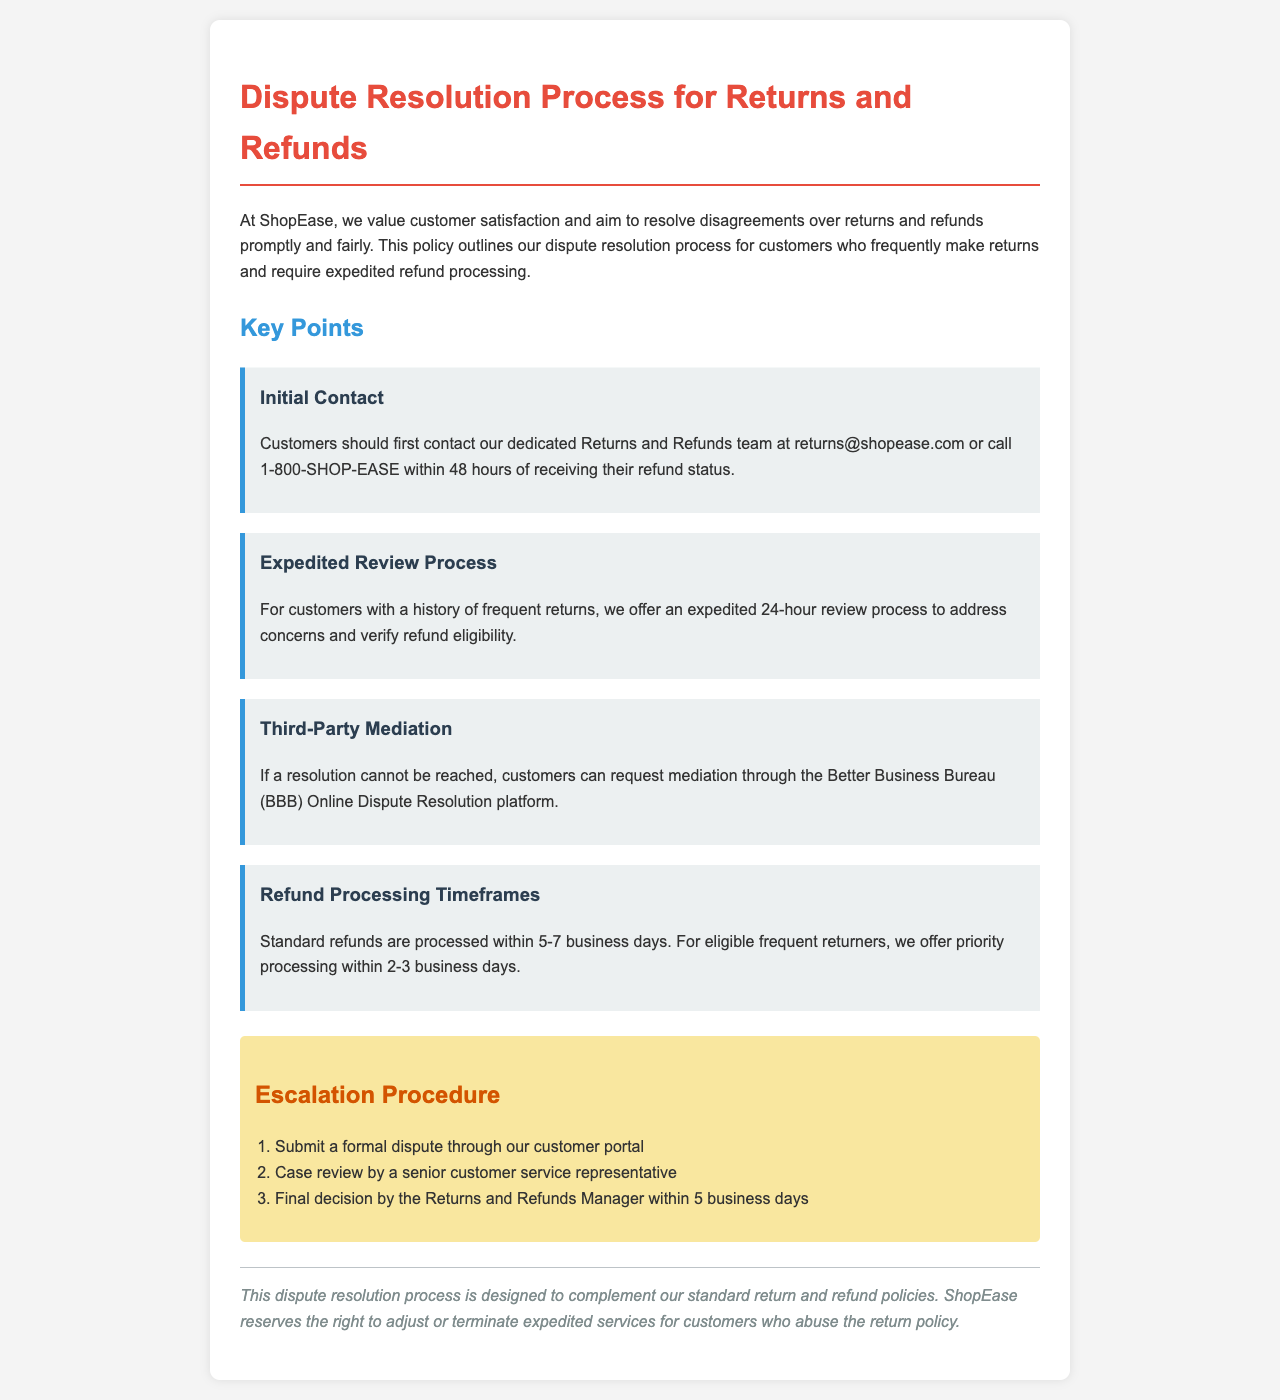What is the email address for the Returns and Refunds team? The email address for the Returns and Refunds team is found in the section describing initial contact.
Answer: returns@shopease.com What is the phone number for the Returns and Refunds team? The phone number is specified in the same section as the email address for contacting the Returns and Refunds team.
Answer: 1-800-SHOP-EASE How long does the expedited review process for frequent returners take? The expedited review process duration is mentioned under the "Expedited Review Process" key point.
Answer: 24 hours What are the standard refund processing timeframes? The standard refund processing timeframes are detailed in the section about refund processing timeframes.
Answer: 5-7 business days What is the priority processing timeframe for eligible frequent returners? The priority processing timeframe is mentioned alongside the standard refund processing timeframes.
Answer: 2-3 business days What is the first step in the escalation procedure? The first step in the escalation procedure is listed in the "Escalation Procedure" section of the document.
Answer: Submit a formal dispute through our customer portal Which organization can customers request mediation through if a resolution cannot be reached? The organization for mediation is specified in the "Third-Party Mediation" key point.
Answer: Better Business Bureau (BBB) Who makes the final decision in the escalation process? The final decision-maker is identified in the escalation procedure section of the document.
Answer: Returns and Refunds Manager What might cause expedited services to be adjusted or terminated? The conditions for adjusting or terminating expedited services are outlined in the disclaimer section.
Answer: Abuse of the return policy 